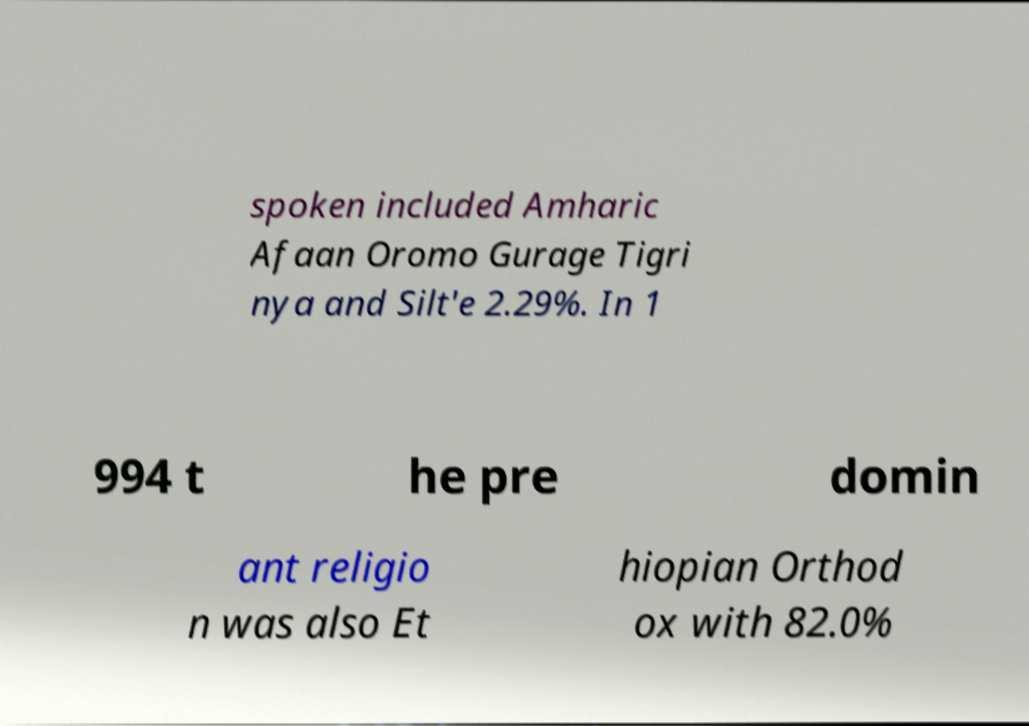What messages or text are displayed in this image? I need them in a readable, typed format. spoken included Amharic Afaan Oromo Gurage Tigri nya and Silt'e 2.29%. In 1 994 t he pre domin ant religio n was also Et hiopian Orthod ox with 82.0% 